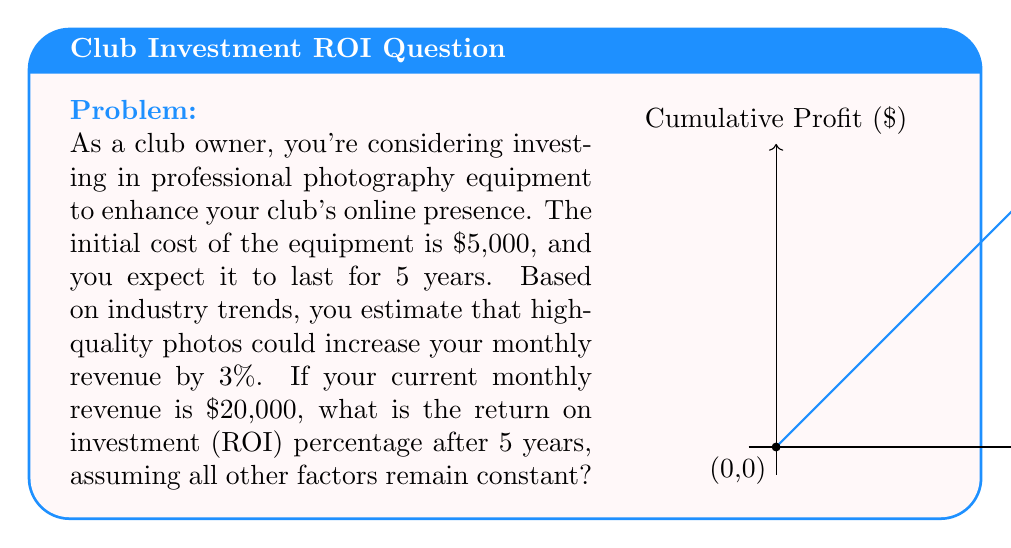Can you answer this question? Let's break this down step-by-step:

1) First, calculate the monthly increase in revenue:
   $20,000 \times 3\% = $600$

2) Calculate the annual increase in revenue:
   $600 \times 12 \text{ months} = $7,200$ per year

3) Calculate the total increase in revenue over 5 years:
   $7,200 \times 5 \text{ years} = $36,000$

4) Calculate the net profit by subtracting the initial investment:
   $36,000 - $5,000 = $31,000$

5) To calculate ROI, we use the formula:
   $$\text{ROI} = \frac{\text{Net Profit}}{\text{Cost of Investment}} \times 100\%$$

6) Plug in the values:
   $$\text{ROI} = \frac{$31,000}{$5,000} \times 100\% = 6.2 \times 100\% = 620\%$$

Therefore, the ROI after 5 years is 620%.
Answer: 620% 